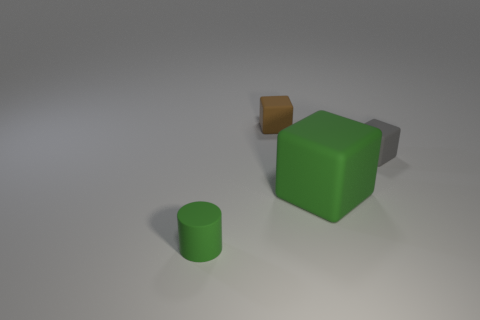There is a rubber object that is to the left of the green matte cube and in front of the gray thing; what is its size?
Your answer should be compact. Small. What color is the object behind the small rubber block right of the brown rubber cube?
Give a very brief answer. Brown. How many cubes are either big things or gray matte things?
Offer a terse response. 2. What number of cubes are left of the matte block in front of the small object that is on the right side of the small brown cube?
Offer a terse response. 1. There is a matte block that is the same color as the rubber cylinder; what size is it?
Make the answer very short. Large. Is there a big red cylinder made of the same material as the big green thing?
Provide a short and direct response. No. Does the brown object have the same material as the small green thing?
Provide a succinct answer. Yes. There is a green object on the right side of the cylinder; how many cubes are behind it?
Offer a very short reply. 2. What number of yellow things are big shiny cylinders or matte cubes?
Give a very brief answer. 0. The green object in front of the green rubber object behind the small rubber object left of the small brown thing is what shape?
Ensure brevity in your answer.  Cylinder. 